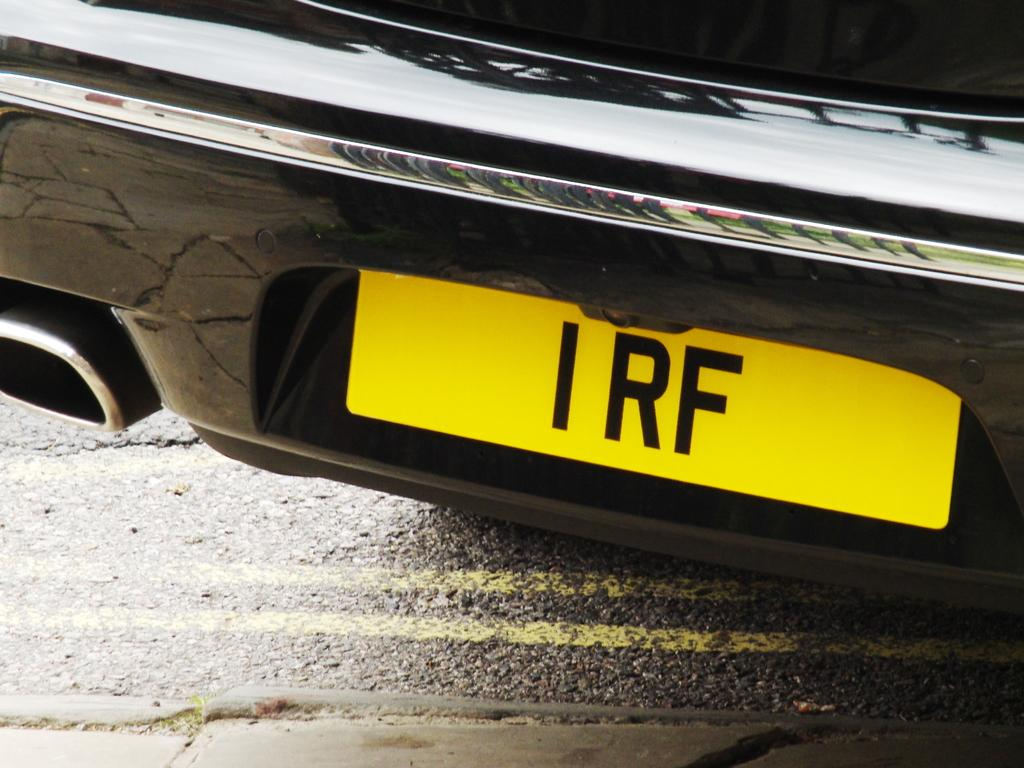What is the main subject of the image? The main subject of the image is a vehicle. What can be seen on the vehicle? The vehicle has text on it. How much of the vehicle is visible in the image? The vehicle is truncated or partially visible. What else can be seen in the image besides the vehicle? There is a road in the image. How much of the road is visible in the image? The road is truncated or partially visible. Can you tell me how many loaves of bread are stacked on the vehicle in the image? There is no loaf of bread present in the image; the vehicle has text on it. What color is the goldfish swimming in the road in the image? There is no goldfish present in the image; the road is partially visible. 